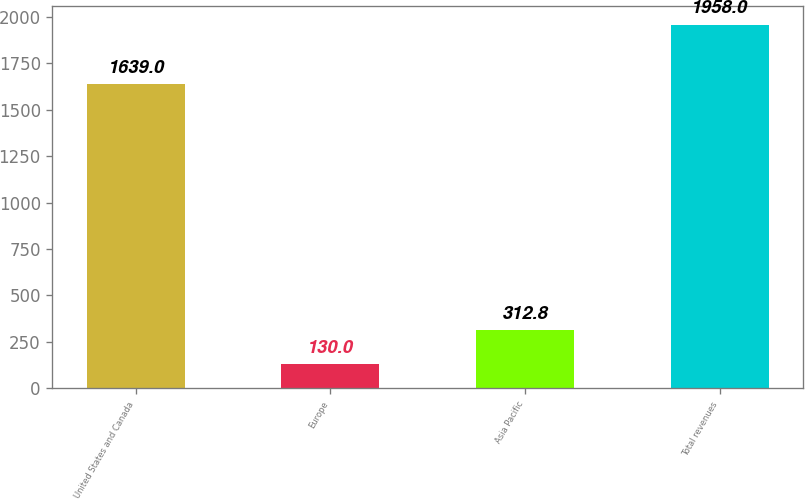<chart> <loc_0><loc_0><loc_500><loc_500><bar_chart><fcel>United States and Canada<fcel>Europe<fcel>Asia Pacific<fcel>Total revenues<nl><fcel>1639<fcel>130<fcel>312.8<fcel>1958<nl></chart> 